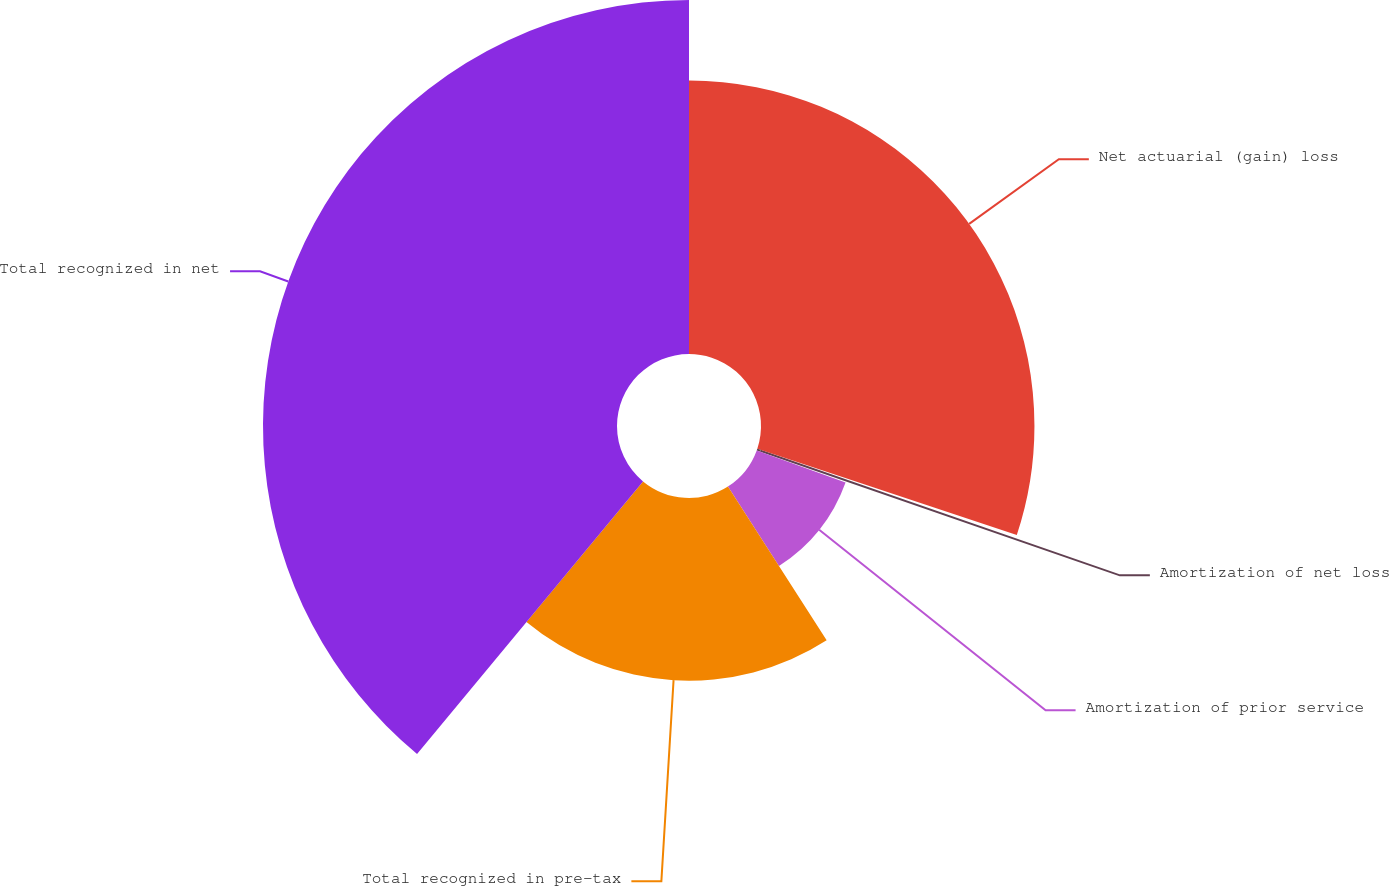Convert chart. <chart><loc_0><loc_0><loc_500><loc_500><pie_chart><fcel>Net actuarial (gain) loss<fcel>Amortization of net loss<fcel>Amortization of prior service<fcel>Total recognized in pre-tax<fcel>Total recognized in net<nl><fcel>30.11%<fcel>0.4%<fcel>10.4%<fcel>20.11%<fcel>38.98%<nl></chart> 